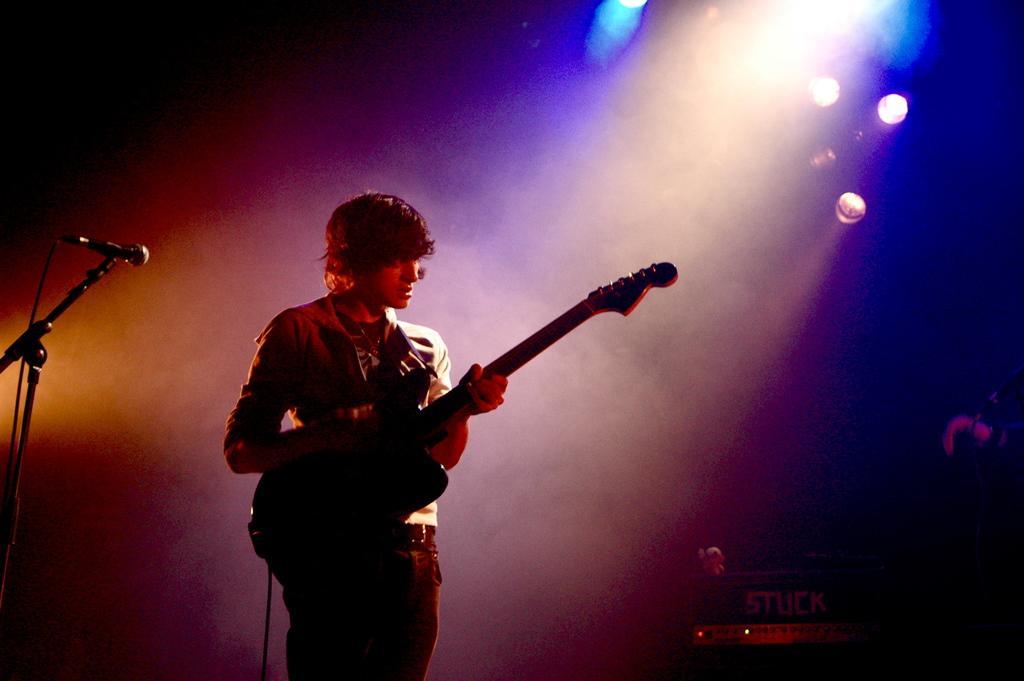In one or two sentences, can you explain what this image depicts? In this image i can see a man is playing a guitar in front of a microphone. 